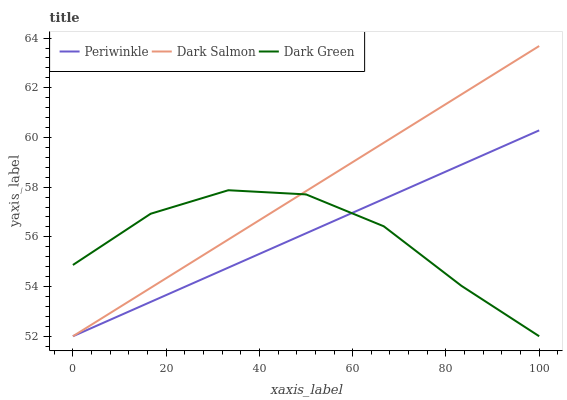Does Dark Green have the minimum area under the curve?
Answer yes or no. Yes. Does Dark Salmon have the maximum area under the curve?
Answer yes or no. Yes. Does Dark Salmon have the minimum area under the curve?
Answer yes or no. No. Does Dark Green have the maximum area under the curve?
Answer yes or no. No. Is Periwinkle the smoothest?
Answer yes or no. Yes. Is Dark Green the roughest?
Answer yes or no. Yes. Is Dark Salmon the smoothest?
Answer yes or no. No. Is Dark Salmon the roughest?
Answer yes or no. No. Does Periwinkle have the lowest value?
Answer yes or no. Yes. Does Dark Salmon have the highest value?
Answer yes or no. Yes. Does Dark Green have the highest value?
Answer yes or no. No. Does Periwinkle intersect Dark Green?
Answer yes or no. Yes. Is Periwinkle less than Dark Green?
Answer yes or no. No. Is Periwinkle greater than Dark Green?
Answer yes or no. No. 